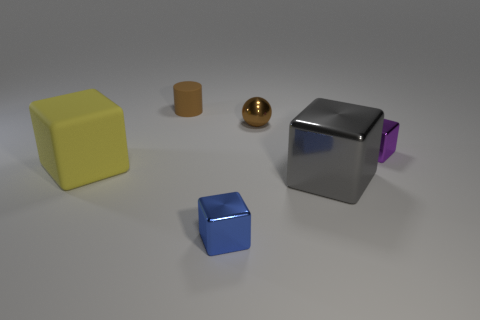There is a matte object that is in front of the small purple metal object; does it have the same shape as the tiny shiny thing that is in front of the purple thing?
Provide a succinct answer. Yes. What shape is the tiny matte thing that is the same color as the small ball?
Your response must be concise. Cylinder. What number of other small blocks have the same material as the small blue block?
Keep it short and to the point. 1. What shape is the tiny thing that is both behind the large gray metallic object and on the left side of the tiny metallic ball?
Provide a succinct answer. Cylinder. Do the large cube that is to the right of the large yellow matte block and the big yellow thing have the same material?
Offer a very short reply. No. What is the color of the block that is the same size as the purple metallic thing?
Provide a short and direct response. Blue. Are there any tiny matte cylinders of the same color as the ball?
Offer a terse response. Yes. There is a gray block that is made of the same material as the small brown sphere; what size is it?
Ensure brevity in your answer.  Large. What number of other things are the same size as the matte cylinder?
Offer a terse response. 3. There is a small block that is left of the purple cube; what is it made of?
Keep it short and to the point. Metal. 